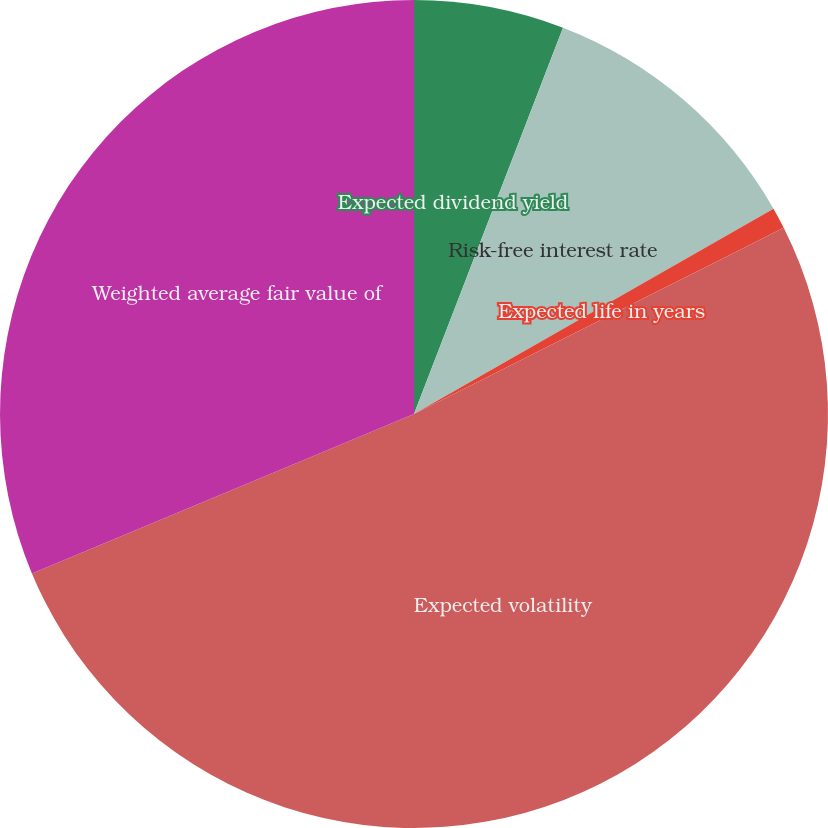Convert chart to OTSL. <chart><loc_0><loc_0><loc_500><loc_500><pie_chart><fcel>Expected dividend yield<fcel>Risk-free interest rate<fcel>Expected life in years<fcel>Expected volatility<fcel>Weighted average fair value of<nl><fcel>5.86%<fcel>10.88%<fcel>0.83%<fcel>51.14%<fcel>31.29%<nl></chart> 